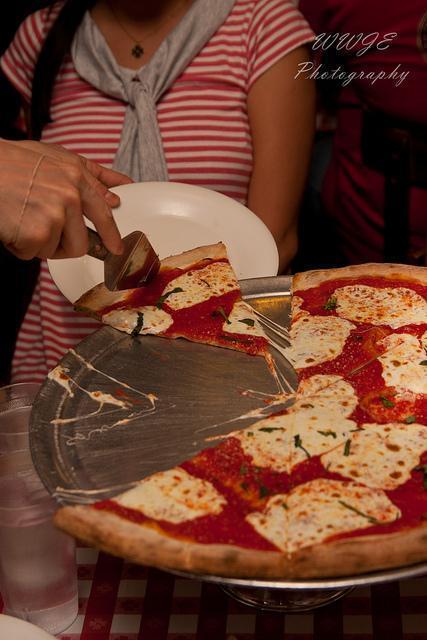How many cups of sugar in the recipe?
Give a very brief answer. 0. How many pieces are missing?
Give a very brief answer. 2. How many pieces of pizza are left?
Give a very brief answer. 6. How many pizzas are there?
Give a very brief answer. 2. How many giraffes are here?
Give a very brief answer. 0. 